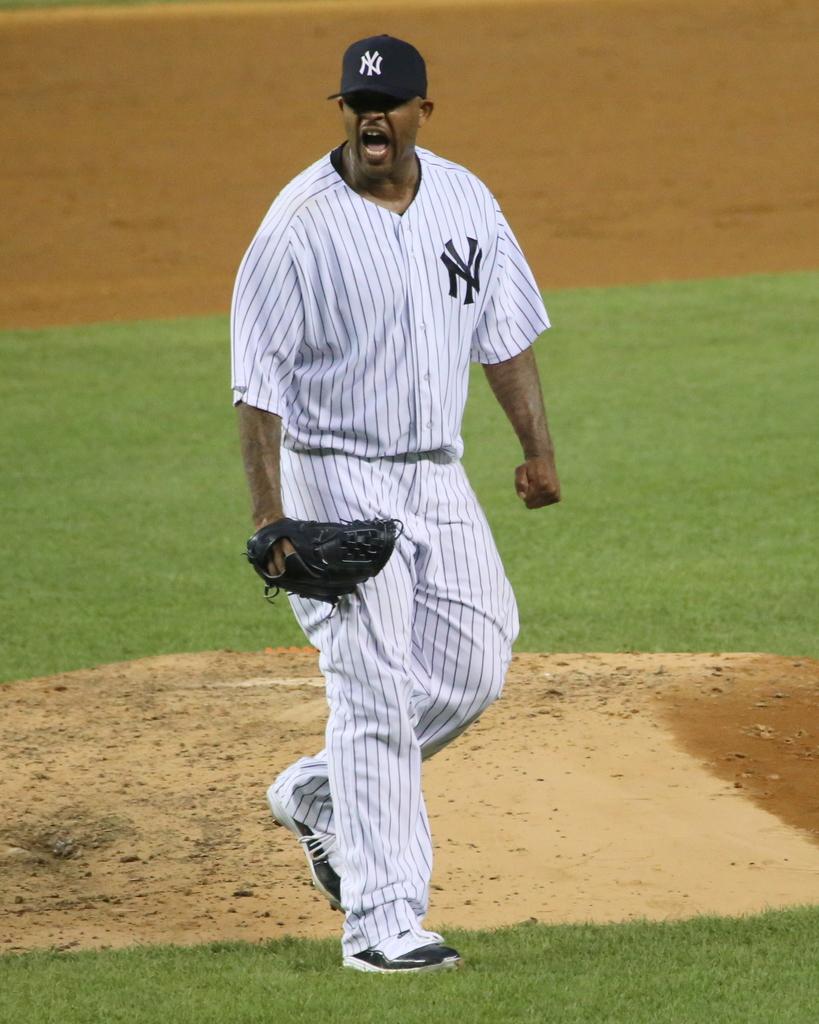What initials are on the players jersey?
Keep it short and to the point. Ny. What team does this man play for?
Your answer should be compact. New york. 